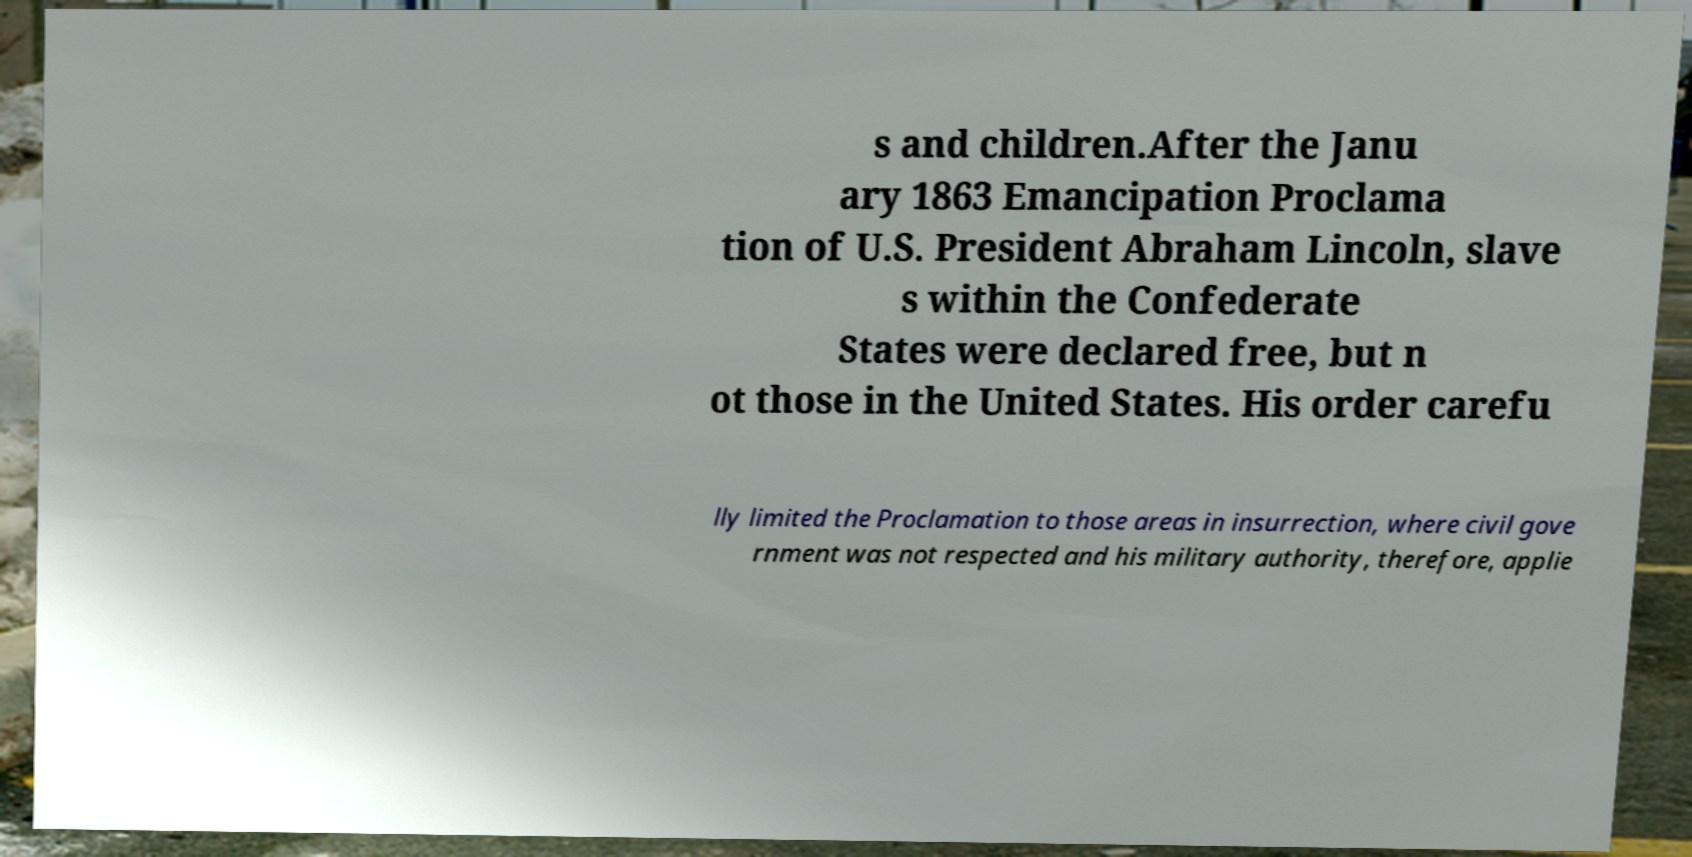Please identify and transcribe the text found in this image. s and children.After the Janu ary 1863 Emancipation Proclama tion of U.S. President Abraham Lincoln, slave s within the Confederate States were declared free, but n ot those in the United States. His order carefu lly limited the Proclamation to those areas in insurrection, where civil gove rnment was not respected and his military authority, therefore, applie 